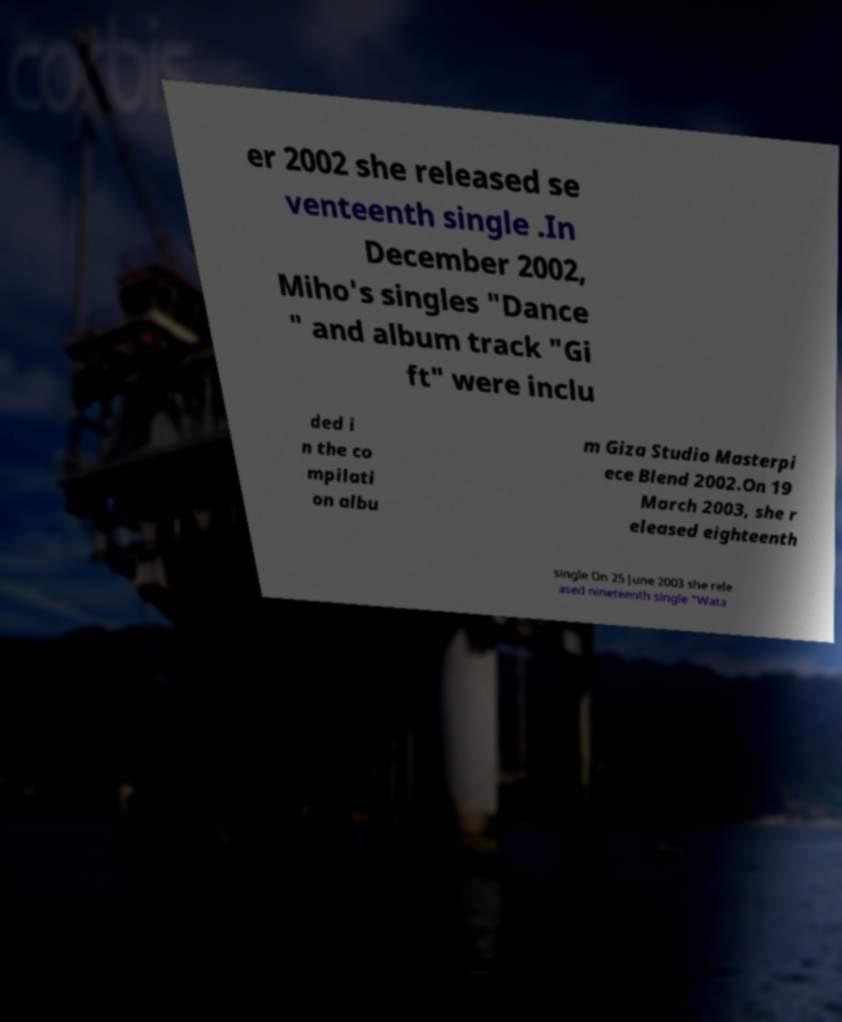Could you assist in decoding the text presented in this image and type it out clearly? er 2002 she released se venteenth single .In December 2002, Miho's singles "Dance " and album track "Gi ft" were inclu ded i n the co mpilati on albu m Giza Studio Masterpi ece Blend 2002.On 19 March 2003, she r eleased eighteenth single On 25 June 2003 she rele ased nineteenth single "Wata 